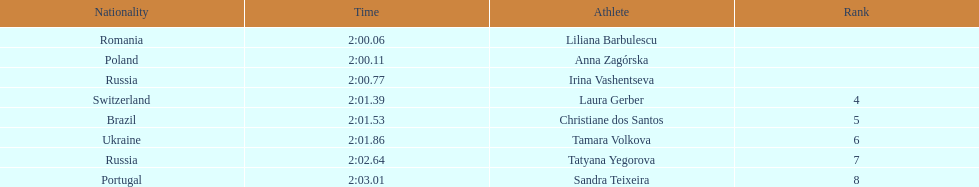Which country had the highest number of finishers in the top 8? Russia. 